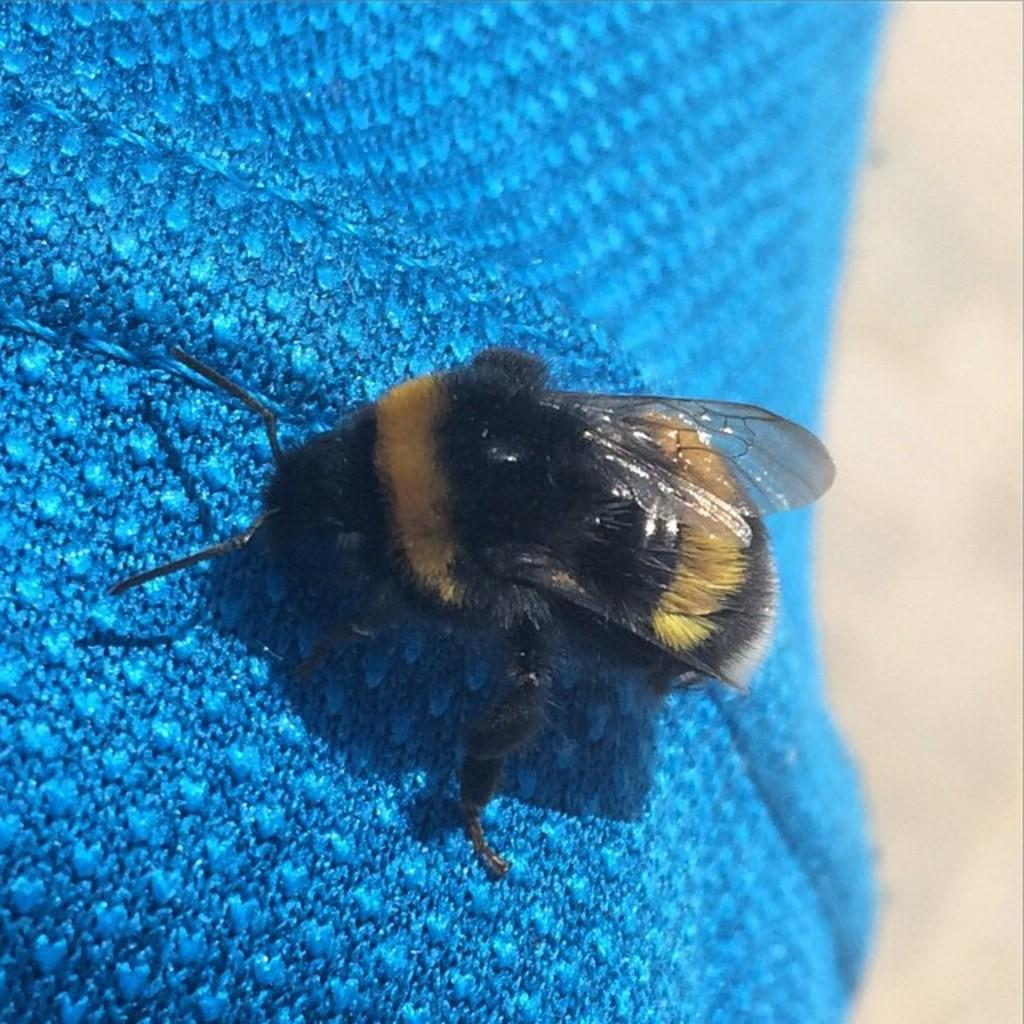What is the main subject in the center of the image? There is an insect in the center of the image. What is the insect situated on? The insect is on a blue color cloth. What type of bird can be seen expanding its wings in the image? There is no bird present in the image, and therefore no such expansion can be observed. 